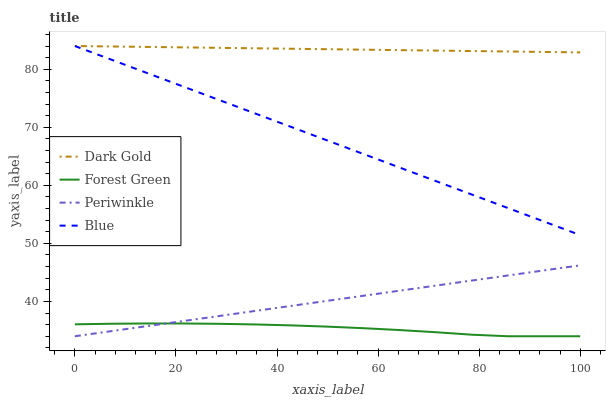Does Forest Green have the minimum area under the curve?
Answer yes or no. Yes. Does Dark Gold have the maximum area under the curve?
Answer yes or no. Yes. Does Periwinkle have the minimum area under the curve?
Answer yes or no. No. Does Periwinkle have the maximum area under the curve?
Answer yes or no. No. Is Periwinkle the smoothest?
Answer yes or no. Yes. Is Forest Green the roughest?
Answer yes or no. Yes. Is Forest Green the smoothest?
Answer yes or no. No. Is Periwinkle the roughest?
Answer yes or no. No. Does Forest Green have the lowest value?
Answer yes or no. Yes. Does Dark Gold have the lowest value?
Answer yes or no. No. Does Dark Gold have the highest value?
Answer yes or no. Yes. Does Periwinkle have the highest value?
Answer yes or no. No. Is Periwinkle less than Dark Gold?
Answer yes or no. Yes. Is Dark Gold greater than Forest Green?
Answer yes or no. Yes. Does Periwinkle intersect Forest Green?
Answer yes or no. Yes. Is Periwinkle less than Forest Green?
Answer yes or no. No. Is Periwinkle greater than Forest Green?
Answer yes or no. No. Does Periwinkle intersect Dark Gold?
Answer yes or no. No. 